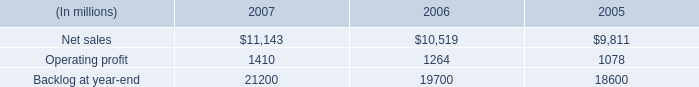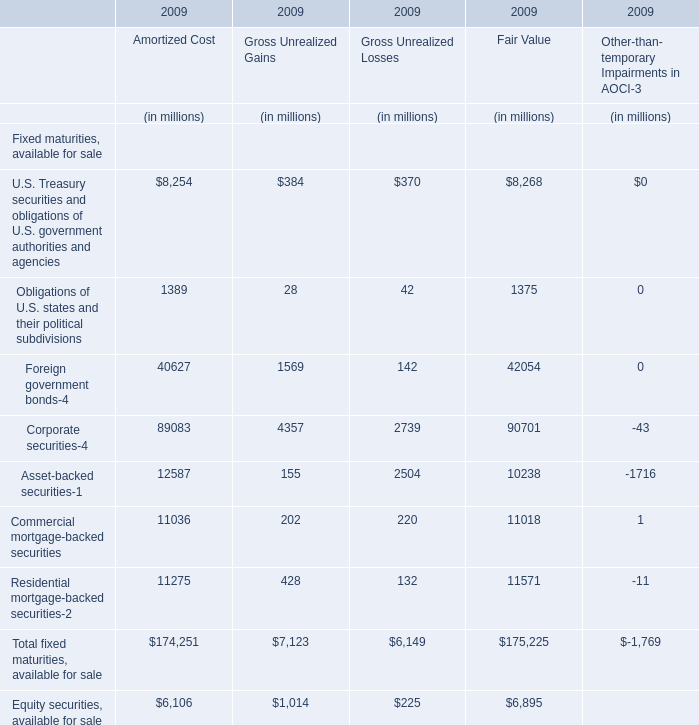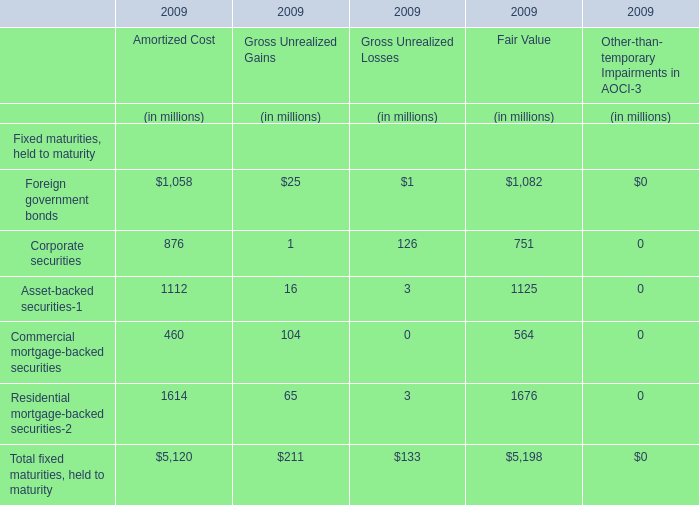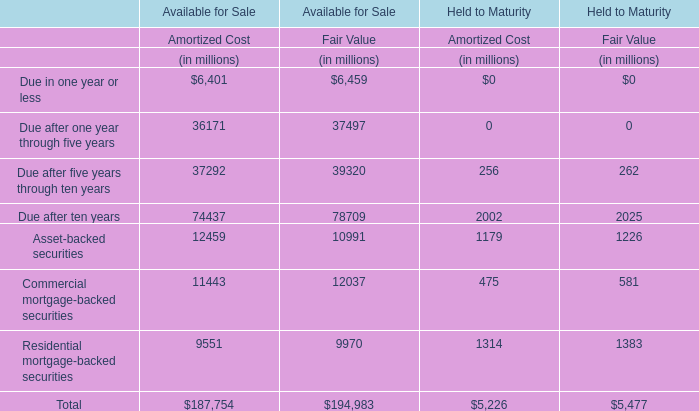What is the Fair Value for the Corporate securities in 2009? (in million) 
Answer: 751. 